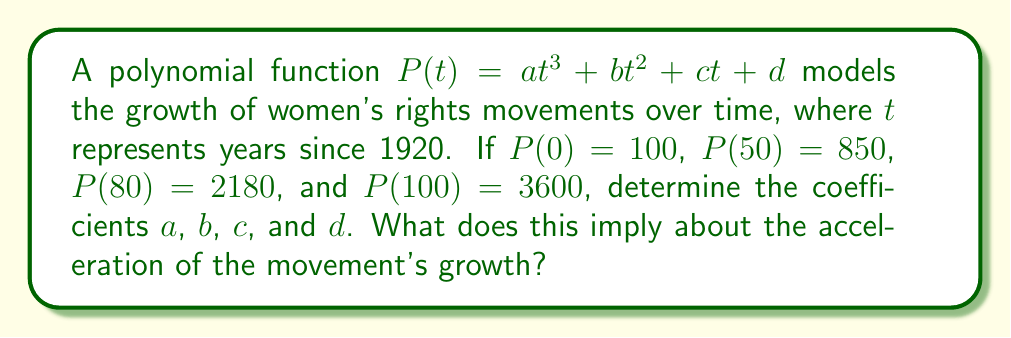Give your solution to this math problem. 1) First, we set up a system of equations using the given information:

   $d = 100$ (since $P(0) = 100$)
   $a(50)^3 + b(50)^2 + c(50) + 100 = 850$
   $a(80)^3 + b(80)^2 + c(80) + 100 = 2180$
   $a(100)^3 + b(100)^2 + c(100) + 100 = 3600$

2) Simplify:

   $125000a + 2500b + 50c = 750$
   $512000a + 6400b + 80c = 2080$
   $1000000a + 10000b + 100c = 3500$

3) Solve this system of equations (using elimination or substitution):

   $a = 0.002$
   $b = 0.05$
   $c = 5$
   $d = 100$

4) Therefore, $P(t) = 0.002t^3 + 0.05t^2 + 5t + 100$

5) The second derivative of $P(t)$ represents the acceleration of growth:

   $P'(t) = 0.006t^2 + 0.1t + 5$
   $P''(t) = 0.012t + 0.1$

6) Since $P''(t)$ is always positive for $t \geq 0$, the acceleration is always increasing.
Answer: $P(t) = 0.002t^3 + 0.05t^2 + 5t + 100$; Acceleration of growth is always increasing. 